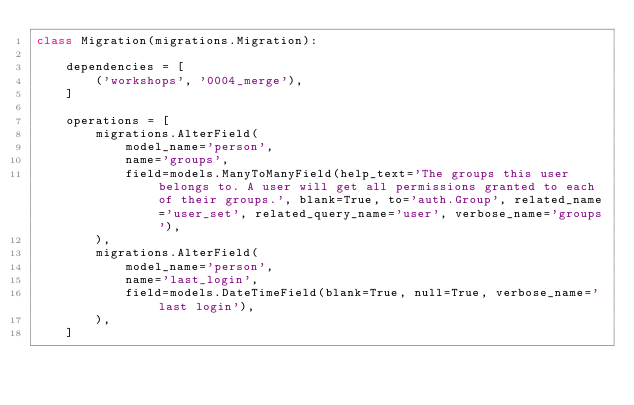<code> <loc_0><loc_0><loc_500><loc_500><_Python_>class Migration(migrations.Migration):

    dependencies = [
        ('workshops', '0004_merge'),
    ]

    operations = [
        migrations.AlterField(
            model_name='person',
            name='groups',
            field=models.ManyToManyField(help_text='The groups this user belongs to. A user will get all permissions granted to each of their groups.', blank=True, to='auth.Group', related_name='user_set', related_query_name='user', verbose_name='groups'),
        ),
        migrations.AlterField(
            model_name='person',
            name='last_login',
            field=models.DateTimeField(blank=True, null=True, verbose_name='last login'),
        ),
    ]
</code> 